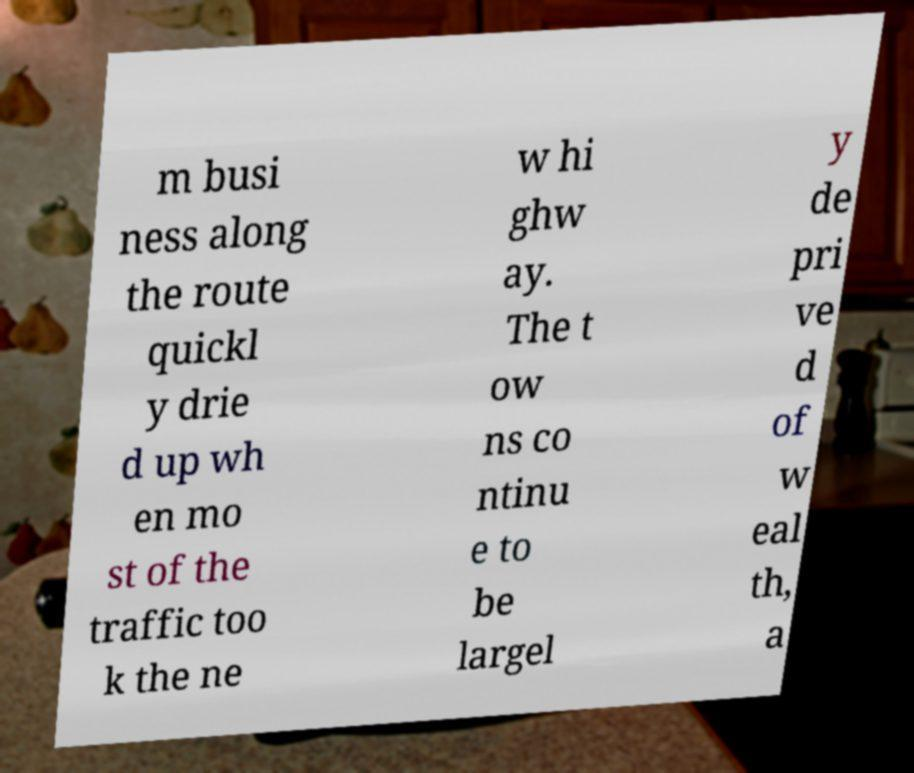Can you read and provide the text displayed in the image?This photo seems to have some interesting text. Can you extract and type it out for me? m busi ness along the route quickl y drie d up wh en mo st of the traffic too k the ne w hi ghw ay. The t ow ns co ntinu e to be largel y de pri ve d of w eal th, a 